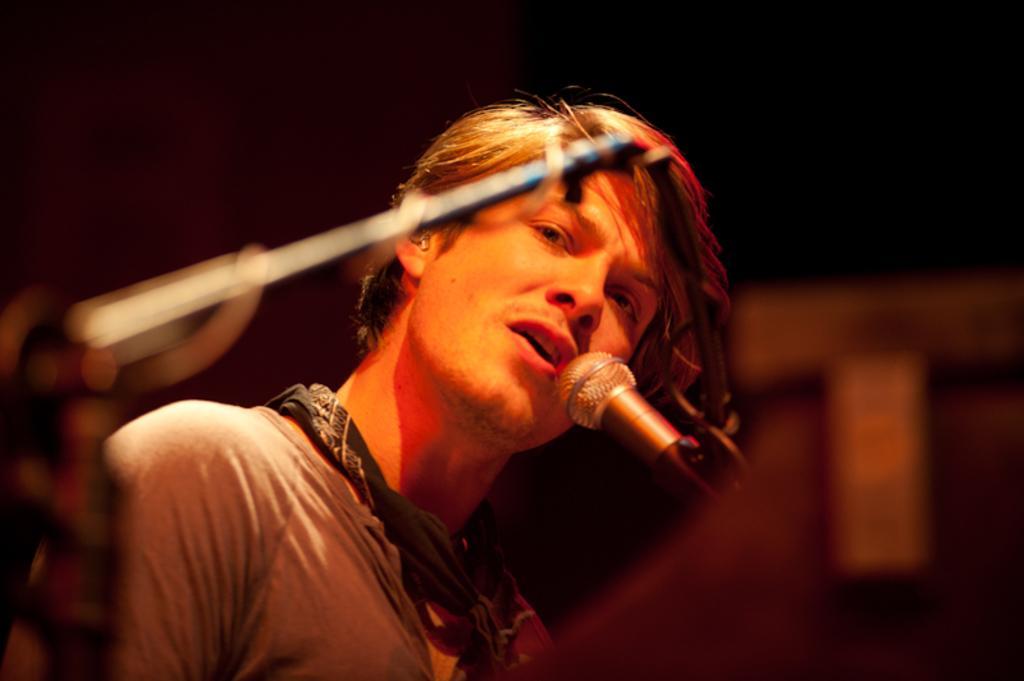How would you summarize this image in a sentence or two? In this picture we can see a man, mic, some objects and in the background it is blurry. 